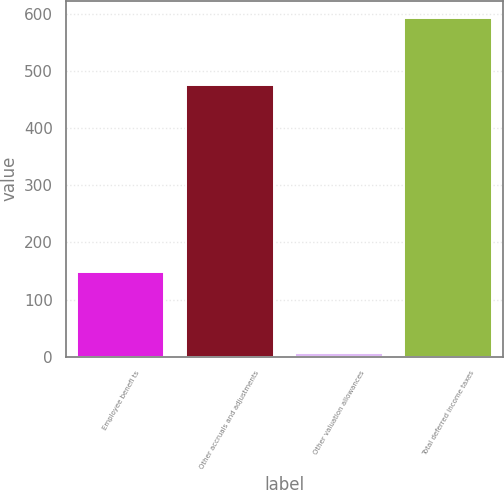Convert chart to OTSL. <chart><loc_0><loc_0><loc_500><loc_500><bar_chart><fcel>Employee benefi ts<fcel>Other accruals and adjustments<fcel>Other valuation allowances<fcel>Total deferred income taxes<nl><fcel>148<fcel>476<fcel>7<fcel>593<nl></chart> 